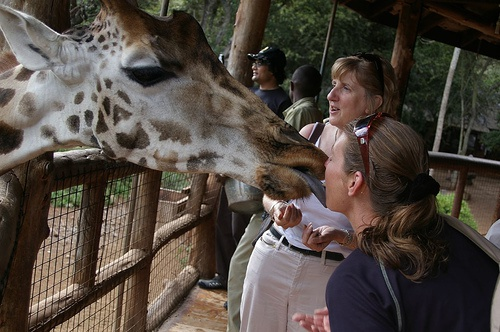Describe the objects in this image and their specific colors. I can see giraffe in gray, darkgray, black, and maroon tones, people in gray, black, maroon, and brown tones, people in gray and black tones, people in gray, black, and maroon tones, and people in gray, black, and darkgray tones in this image. 